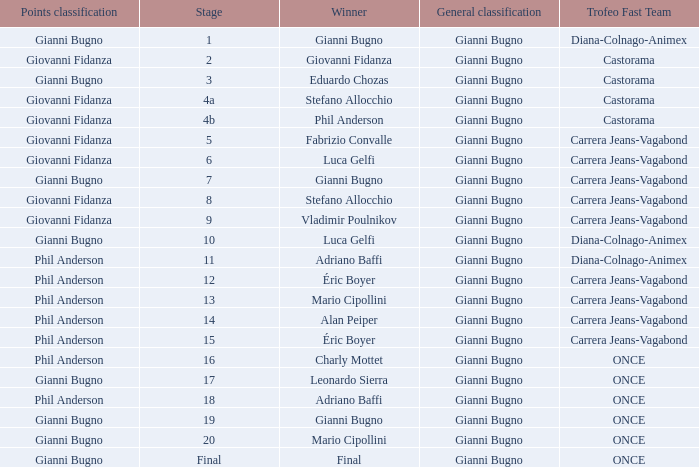Who is the trofeo fast team in stage 10? Diana-Colnago-Animex. 